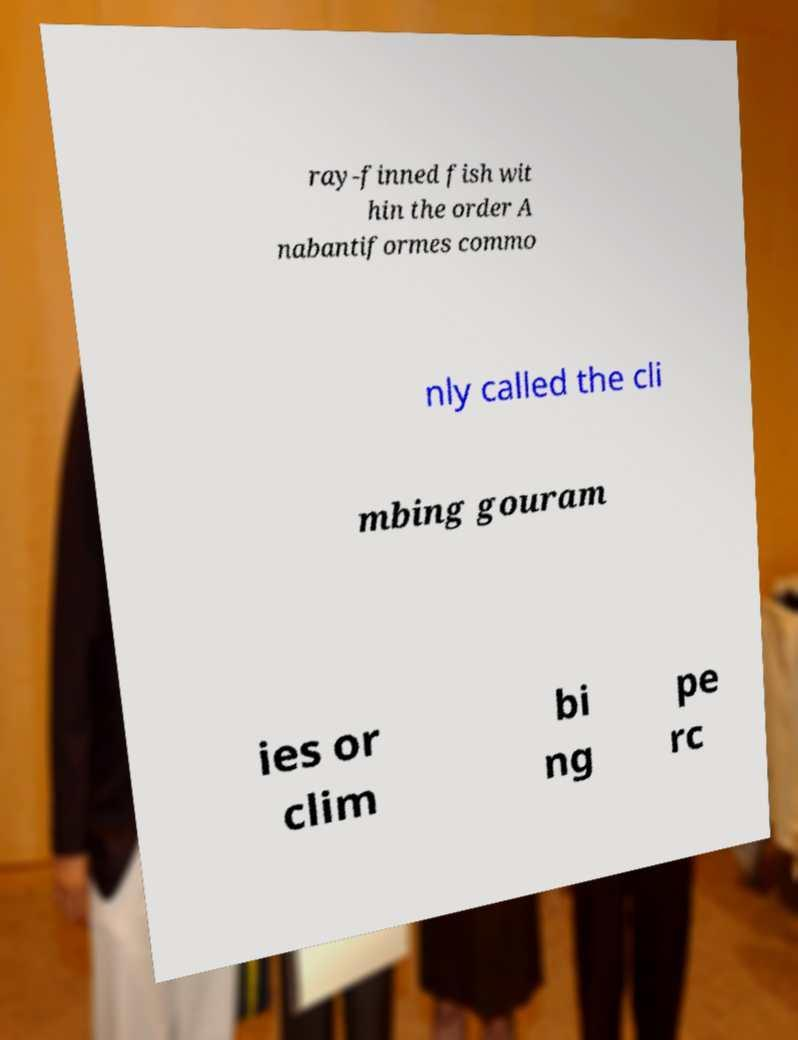Could you extract and type out the text from this image? ray-finned fish wit hin the order A nabantiformes commo nly called the cli mbing gouram ies or clim bi ng pe rc 